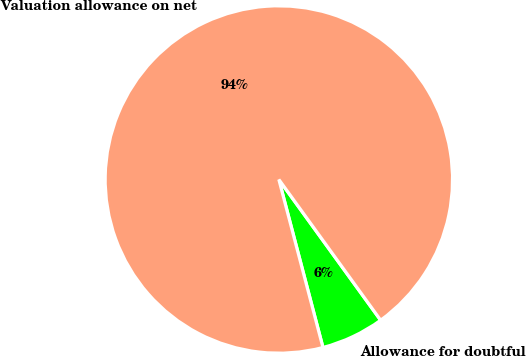Convert chart. <chart><loc_0><loc_0><loc_500><loc_500><pie_chart><fcel>Allowance for doubtful<fcel>Valuation allowance on net<nl><fcel>5.88%<fcel>94.12%<nl></chart> 